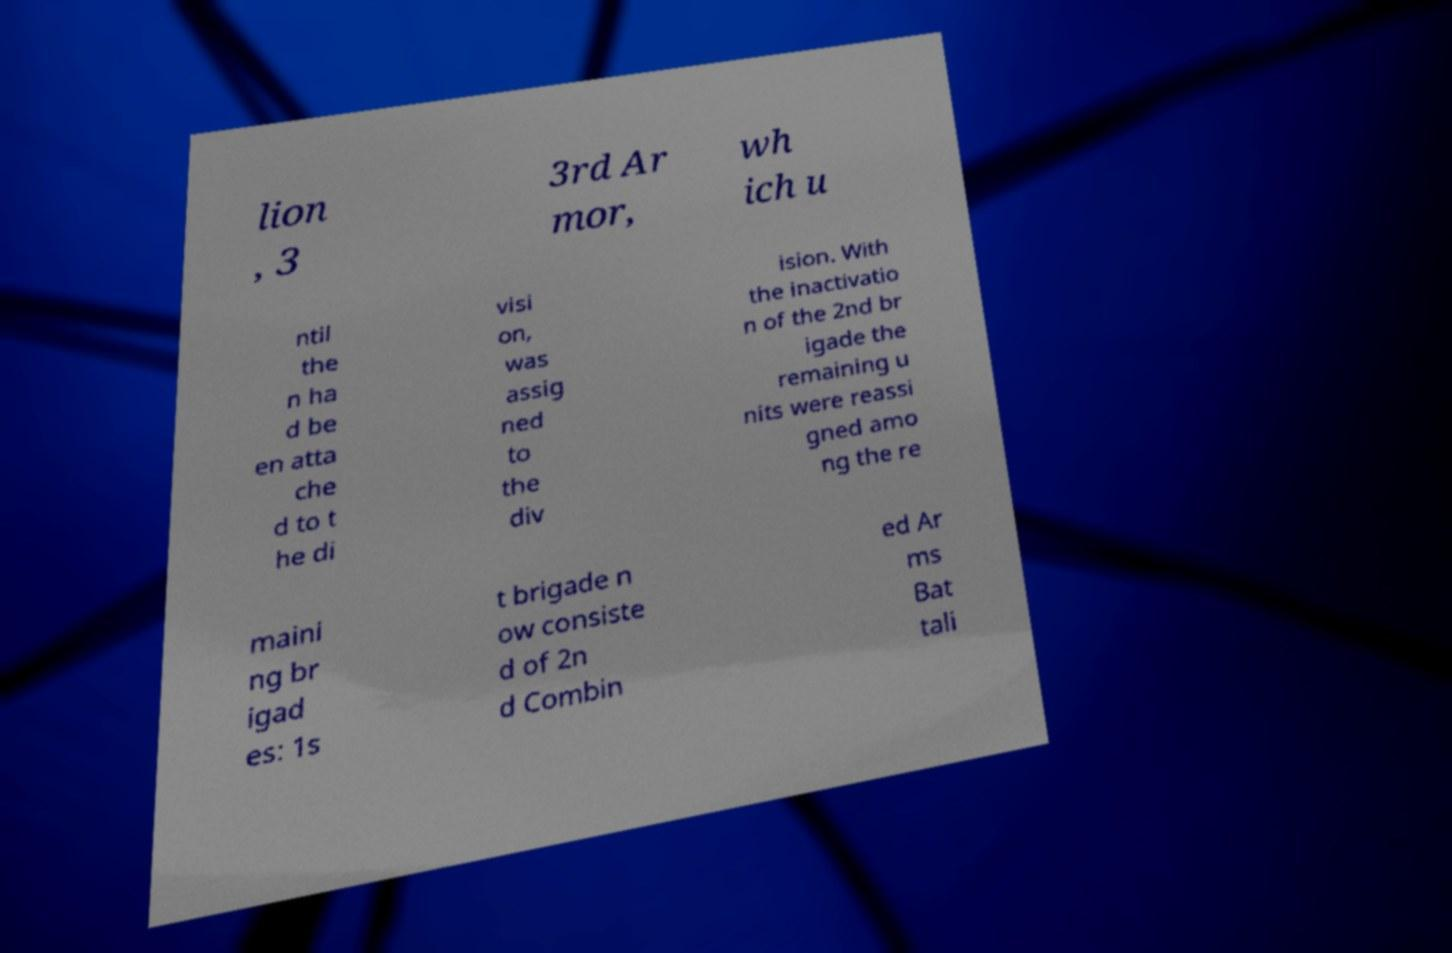Can you read and provide the text displayed in the image?This photo seems to have some interesting text. Can you extract and type it out for me? lion , 3 3rd Ar mor, wh ich u ntil the n ha d be en atta che d to t he di visi on, was assig ned to the div ision. With the inactivatio n of the 2nd br igade the remaining u nits were reassi gned amo ng the re maini ng br igad es: 1s t brigade n ow consiste d of 2n d Combin ed Ar ms Bat tali 